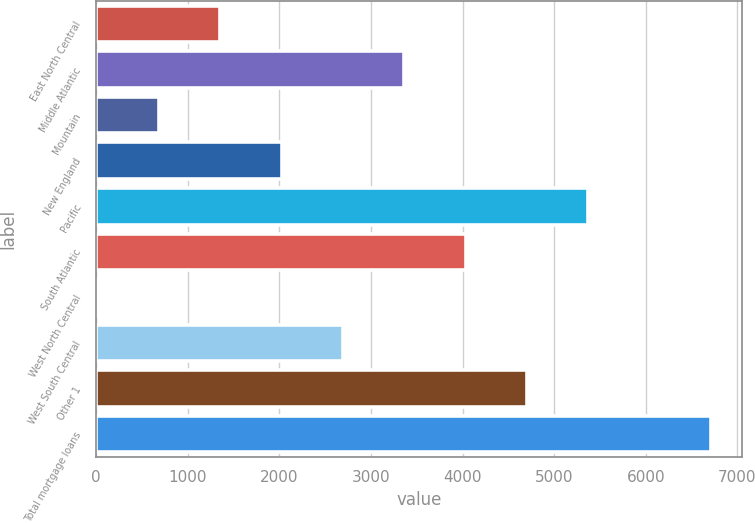<chart> <loc_0><loc_0><loc_500><loc_500><bar_chart><fcel>East North Central<fcel>Middle Atlantic<fcel>Mountain<fcel>New England<fcel>Pacific<fcel>South Atlantic<fcel>West North Central<fcel>West South Central<fcel>Other 1<fcel>Total mortgage loans<nl><fcel>1355<fcel>3363.5<fcel>685.5<fcel>2024.5<fcel>5372<fcel>4033<fcel>16<fcel>2694<fcel>4702.5<fcel>6711<nl></chart> 